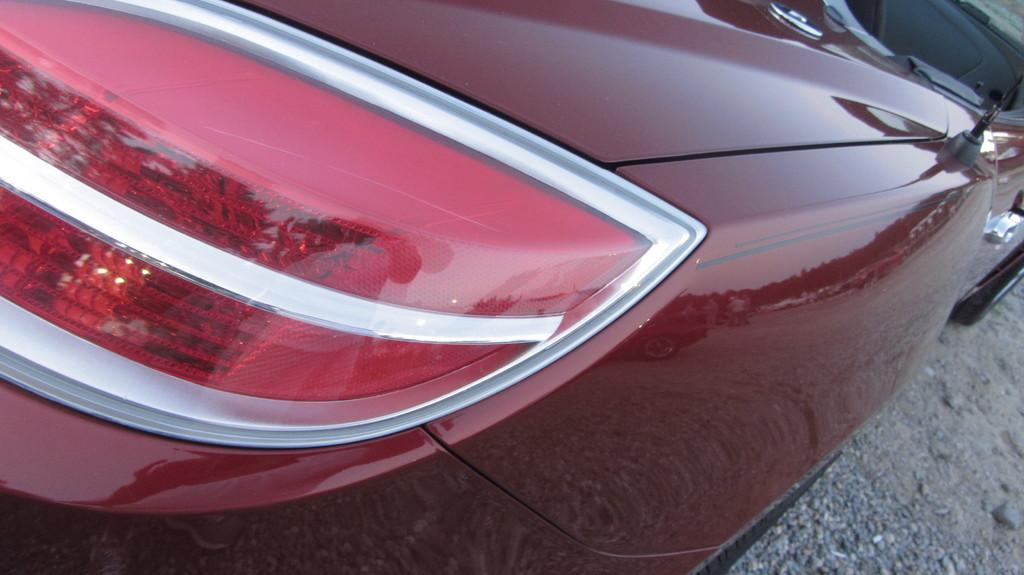What is the main subject in the center of the image? There is a vehicle in the center of the image. What type of surface is visible at the bottom of the image? There is a road at the bottom of the image. What type of party is being held in the image? There is no party present in the image; it features a vehicle and a road. What adjustments need to be made to the paint in the image? There is no mention of paint or any adjustments required in the image. 